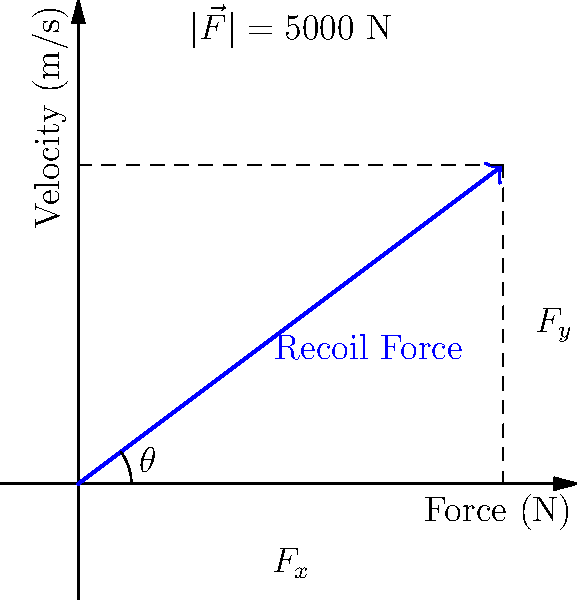A 19th-century cannon fires a 12 kg cannonball with a muzzle velocity of 250 m/s. The recoil force vector is shown in the diagram. Calculate the angle $\theta$ between the recoil force vector and the horizontal axis. To find the angle $\theta$, we need to use trigonometry. The recoil force vector can be broken down into its horizontal ($F_x$) and vertical ($F_y$) components.

Step 1: Identify the known values
- The magnitude of the recoil force $|\vec{F}| = 5000$ N
- The horizontal component $F_x = 4$ units
- The vertical component $F_y = 3$ units

Step 2: Use the arctangent function to calculate the angle
The angle $\theta$ can be found using:

$$\theta = \arctan(\frac{F_y}{F_x})$$

Step 3: Substitute the values
$$\theta = \arctan(\frac{3}{4})$$

Step 4: Calculate the result
$$\theta = \arctan(0.75) \approx 36.87°$$

Therefore, the angle between the recoil force vector and the horizontal axis is approximately 36.87°.
Answer: $36.87°$ 